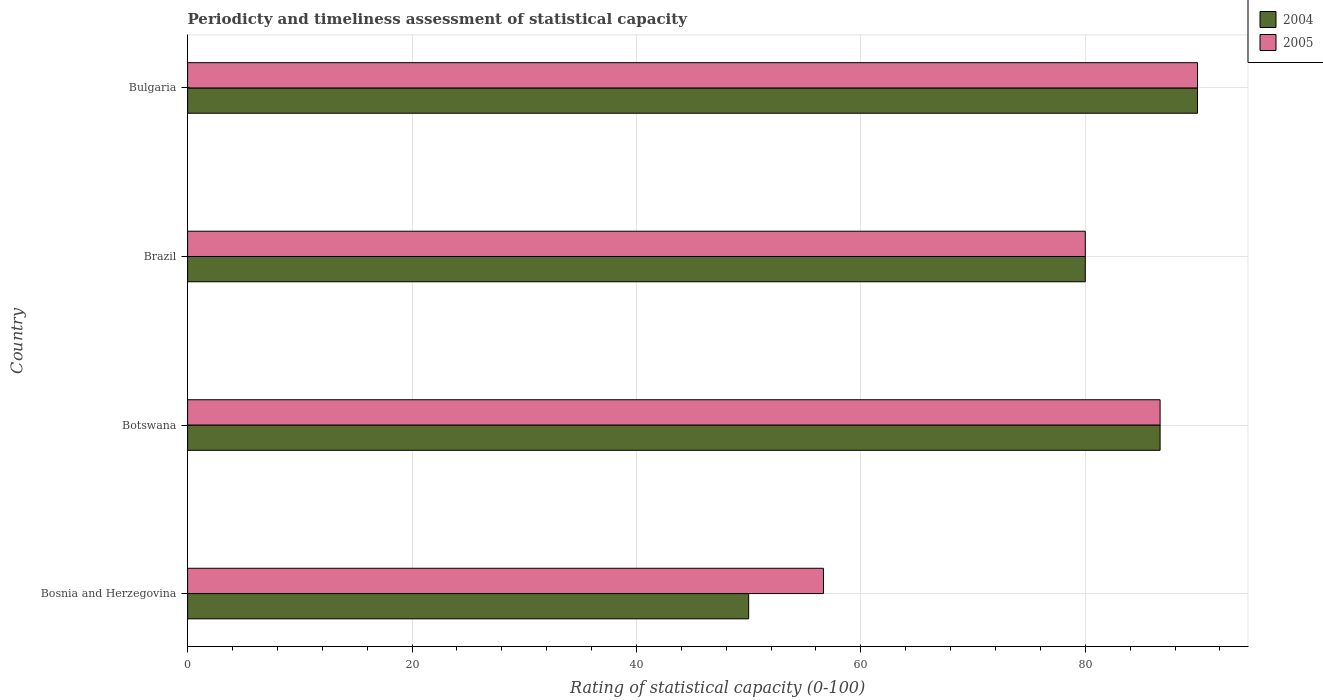How many different coloured bars are there?
Your response must be concise. 2. How many groups of bars are there?
Make the answer very short. 4. Are the number of bars per tick equal to the number of legend labels?
Offer a terse response. Yes. How many bars are there on the 1st tick from the bottom?
Your answer should be compact. 2. What is the label of the 4th group of bars from the top?
Make the answer very short. Bosnia and Herzegovina. Across all countries, what is the maximum rating of statistical capacity in 2004?
Your answer should be very brief. 90. Across all countries, what is the minimum rating of statistical capacity in 2004?
Your answer should be very brief. 50. In which country was the rating of statistical capacity in 2005 minimum?
Ensure brevity in your answer.  Bosnia and Herzegovina. What is the total rating of statistical capacity in 2005 in the graph?
Offer a very short reply. 313.33. What is the difference between the rating of statistical capacity in 2004 in Bosnia and Herzegovina and that in Botswana?
Give a very brief answer. -36.67. What is the difference between the rating of statistical capacity in 2004 in Bulgaria and the rating of statistical capacity in 2005 in Bosnia and Herzegovina?
Offer a terse response. 33.33. What is the average rating of statistical capacity in 2004 per country?
Offer a terse response. 76.67. What is the difference between the rating of statistical capacity in 2005 and rating of statistical capacity in 2004 in Bulgaria?
Offer a very short reply. 0. What is the ratio of the rating of statistical capacity in 2005 in Brazil to that in Bulgaria?
Ensure brevity in your answer.  0.89. What is the difference between the highest and the second highest rating of statistical capacity in 2005?
Offer a terse response. 3.33. What is the difference between the highest and the lowest rating of statistical capacity in 2005?
Offer a terse response. 33.33. Is the sum of the rating of statistical capacity in 2005 in Bosnia and Herzegovina and Botswana greater than the maximum rating of statistical capacity in 2004 across all countries?
Provide a succinct answer. Yes. What does the 1st bar from the top in Bosnia and Herzegovina represents?
Make the answer very short. 2005. What does the 1st bar from the bottom in Botswana represents?
Your response must be concise. 2004. Are all the bars in the graph horizontal?
Make the answer very short. Yes. What is the difference between two consecutive major ticks on the X-axis?
Your answer should be compact. 20. Does the graph contain any zero values?
Offer a very short reply. No. Where does the legend appear in the graph?
Provide a succinct answer. Top right. What is the title of the graph?
Your response must be concise. Periodicty and timeliness assessment of statistical capacity. Does "1960" appear as one of the legend labels in the graph?
Make the answer very short. No. What is the label or title of the X-axis?
Ensure brevity in your answer.  Rating of statistical capacity (0-100). What is the Rating of statistical capacity (0-100) in 2005 in Bosnia and Herzegovina?
Ensure brevity in your answer.  56.67. What is the Rating of statistical capacity (0-100) in 2004 in Botswana?
Make the answer very short. 86.67. What is the Rating of statistical capacity (0-100) in 2005 in Botswana?
Your answer should be very brief. 86.67. What is the Rating of statistical capacity (0-100) of 2004 in Brazil?
Provide a short and direct response. 80. What is the Rating of statistical capacity (0-100) of 2005 in Bulgaria?
Give a very brief answer. 90. Across all countries, what is the maximum Rating of statistical capacity (0-100) of 2004?
Make the answer very short. 90. Across all countries, what is the maximum Rating of statistical capacity (0-100) of 2005?
Make the answer very short. 90. Across all countries, what is the minimum Rating of statistical capacity (0-100) of 2004?
Your answer should be compact. 50. Across all countries, what is the minimum Rating of statistical capacity (0-100) in 2005?
Your answer should be compact. 56.67. What is the total Rating of statistical capacity (0-100) in 2004 in the graph?
Provide a short and direct response. 306.67. What is the total Rating of statistical capacity (0-100) of 2005 in the graph?
Keep it short and to the point. 313.33. What is the difference between the Rating of statistical capacity (0-100) of 2004 in Bosnia and Herzegovina and that in Botswana?
Provide a succinct answer. -36.67. What is the difference between the Rating of statistical capacity (0-100) in 2005 in Bosnia and Herzegovina and that in Botswana?
Offer a terse response. -30. What is the difference between the Rating of statistical capacity (0-100) in 2005 in Bosnia and Herzegovina and that in Brazil?
Offer a terse response. -23.33. What is the difference between the Rating of statistical capacity (0-100) of 2004 in Bosnia and Herzegovina and that in Bulgaria?
Your response must be concise. -40. What is the difference between the Rating of statistical capacity (0-100) of 2005 in Bosnia and Herzegovina and that in Bulgaria?
Keep it short and to the point. -33.33. What is the difference between the Rating of statistical capacity (0-100) of 2004 in Botswana and that in Brazil?
Your answer should be compact. 6.67. What is the difference between the Rating of statistical capacity (0-100) in 2005 in Botswana and that in Brazil?
Offer a terse response. 6.67. What is the difference between the Rating of statistical capacity (0-100) in 2005 in Botswana and that in Bulgaria?
Your answer should be very brief. -3.33. What is the difference between the Rating of statistical capacity (0-100) of 2004 in Brazil and that in Bulgaria?
Ensure brevity in your answer.  -10. What is the difference between the Rating of statistical capacity (0-100) in 2005 in Brazil and that in Bulgaria?
Your response must be concise. -10. What is the difference between the Rating of statistical capacity (0-100) of 2004 in Bosnia and Herzegovina and the Rating of statistical capacity (0-100) of 2005 in Botswana?
Keep it short and to the point. -36.67. What is the difference between the Rating of statistical capacity (0-100) of 2004 in Bosnia and Herzegovina and the Rating of statistical capacity (0-100) of 2005 in Brazil?
Provide a short and direct response. -30. What is the difference between the Rating of statistical capacity (0-100) of 2004 in Bosnia and Herzegovina and the Rating of statistical capacity (0-100) of 2005 in Bulgaria?
Provide a succinct answer. -40. What is the difference between the Rating of statistical capacity (0-100) in 2004 in Botswana and the Rating of statistical capacity (0-100) in 2005 in Brazil?
Your answer should be compact. 6.67. What is the difference between the Rating of statistical capacity (0-100) in 2004 in Botswana and the Rating of statistical capacity (0-100) in 2005 in Bulgaria?
Your answer should be compact. -3.33. What is the difference between the Rating of statistical capacity (0-100) in 2004 in Brazil and the Rating of statistical capacity (0-100) in 2005 in Bulgaria?
Make the answer very short. -10. What is the average Rating of statistical capacity (0-100) of 2004 per country?
Keep it short and to the point. 76.67. What is the average Rating of statistical capacity (0-100) of 2005 per country?
Provide a short and direct response. 78.33. What is the difference between the Rating of statistical capacity (0-100) in 2004 and Rating of statistical capacity (0-100) in 2005 in Bosnia and Herzegovina?
Offer a terse response. -6.67. What is the difference between the Rating of statistical capacity (0-100) in 2004 and Rating of statistical capacity (0-100) in 2005 in Botswana?
Offer a terse response. 0. What is the difference between the Rating of statistical capacity (0-100) of 2004 and Rating of statistical capacity (0-100) of 2005 in Brazil?
Give a very brief answer. 0. What is the difference between the Rating of statistical capacity (0-100) of 2004 and Rating of statistical capacity (0-100) of 2005 in Bulgaria?
Provide a succinct answer. 0. What is the ratio of the Rating of statistical capacity (0-100) of 2004 in Bosnia and Herzegovina to that in Botswana?
Offer a terse response. 0.58. What is the ratio of the Rating of statistical capacity (0-100) in 2005 in Bosnia and Herzegovina to that in Botswana?
Keep it short and to the point. 0.65. What is the ratio of the Rating of statistical capacity (0-100) of 2004 in Bosnia and Herzegovina to that in Brazil?
Keep it short and to the point. 0.62. What is the ratio of the Rating of statistical capacity (0-100) of 2005 in Bosnia and Herzegovina to that in Brazil?
Provide a short and direct response. 0.71. What is the ratio of the Rating of statistical capacity (0-100) in 2004 in Bosnia and Herzegovina to that in Bulgaria?
Your answer should be very brief. 0.56. What is the ratio of the Rating of statistical capacity (0-100) in 2005 in Bosnia and Herzegovina to that in Bulgaria?
Keep it short and to the point. 0.63. What is the ratio of the Rating of statistical capacity (0-100) in 2004 in Botswana to that in Brazil?
Provide a short and direct response. 1.08. What is the ratio of the Rating of statistical capacity (0-100) of 2005 in Botswana to that in Brazil?
Make the answer very short. 1.08. What is the ratio of the Rating of statistical capacity (0-100) in 2004 in Botswana to that in Bulgaria?
Offer a terse response. 0.96. What is the ratio of the Rating of statistical capacity (0-100) of 2005 in Botswana to that in Bulgaria?
Provide a short and direct response. 0.96. What is the ratio of the Rating of statistical capacity (0-100) in 2004 in Brazil to that in Bulgaria?
Give a very brief answer. 0.89. What is the difference between the highest and the second highest Rating of statistical capacity (0-100) of 2004?
Your answer should be compact. 3.33. What is the difference between the highest and the lowest Rating of statistical capacity (0-100) of 2004?
Your answer should be very brief. 40. What is the difference between the highest and the lowest Rating of statistical capacity (0-100) in 2005?
Offer a very short reply. 33.33. 